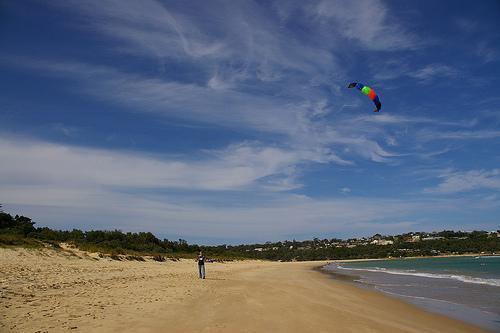How many objects are in the sky?
Give a very brief answer. 1. 